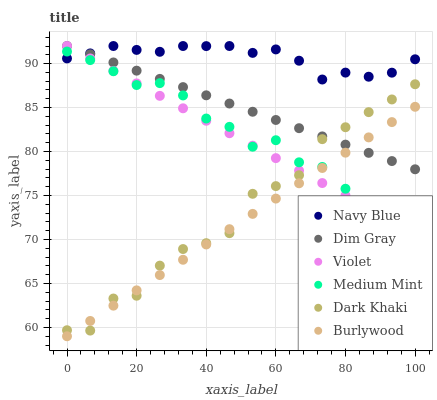Does Burlywood have the minimum area under the curve?
Answer yes or no. Yes. Does Navy Blue have the maximum area under the curve?
Answer yes or no. Yes. Does Dim Gray have the minimum area under the curve?
Answer yes or no. No. Does Dim Gray have the maximum area under the curve?
Answer yes or no. No. Is Violet the smoothest?
Answer yes or no. Yes. Is Dark Khaki the roughest?
Answer yes or no. Yes. Is Dim Gray the smoothest?
Answer yes or no. No. Is Dim Gray the roughest?
Answer yes or no. No. Does Burlywood have the lowest value?
Answer yes or no. Yes. Does Dim Gray have the lowest value?
Answer yes or no. No. Does Violet have the highest value?
Answer yes or no. Yes. Does Burlywood have the highest value?
Answer yes or no. No. Is Burlywood less than Navy Blue?
Answer yes or no. Yes. Is Navy Blue greater than Burlywood?
Answer yes or no. Yes. Does Navy Blue intersect Violet?
Answer yes or no. Yes. Is Navy Blue less than Violet?
Answer yes or no. No. Is Navy Blue greater than Violet?
Answer yes or no. No. Does Burlywood intersect Navy Blue?
Answer yes or no. No. 